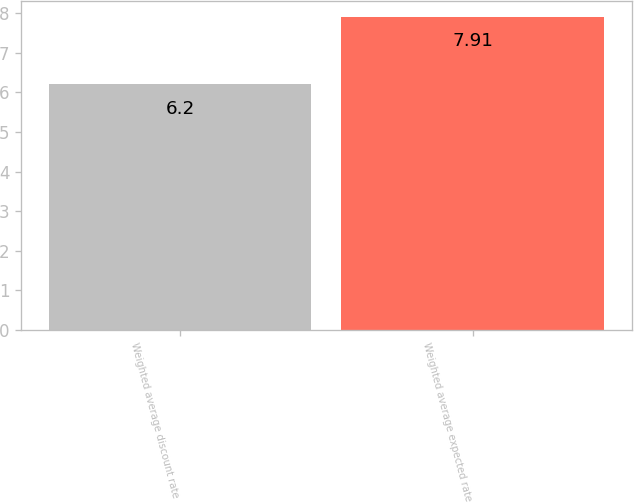<chart> <loc_0><loc_0><loc_500><loc_500><bar_chart><fcel>Weighted average discount rate<fcel>Weighted average expected rate<nl><fcel>6.2<fcel>7.91<nl></chart> 